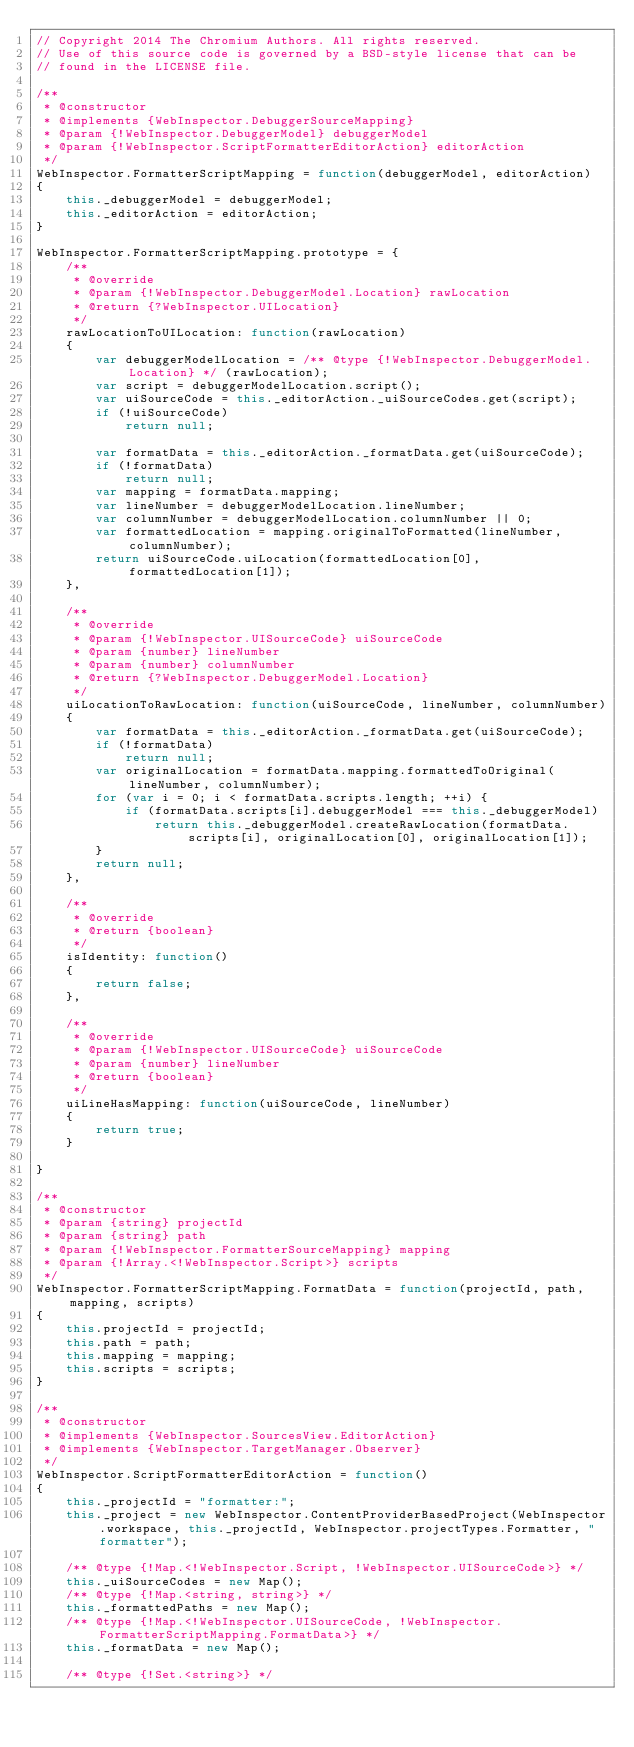Convert code to text. <code><loc_0><loc_0><loc_500><loc_500><_JavaScript_>// Copyright 2014 The Chromium Authors. All rights reserved.
// Use of this source code is governed by a BSD-style license that can be
// found in the LICENSE file.

/**
 * @constructor
 * @implements {WebInspector.DebuggerSourceMapping}
 * @param {!WebInspector.DebuggerModel} debuggerModel
 * @param {!WebInspector.ScriptFormatterEditorAction} editorAction
 */
WebInspector.FormatterScriptMapping = function(debuggerModel, editorAction)
{
    this._debuggerModel = debuggerModel;
    this._editorAction = editorAction;
}

WebInspector.FormatterScriptMapping.prototype = {
    /**
     * @override
     * @param {!WebInspector.DebuggerModel.Location} rawLocation
     * @return {?WebInspector.UILocation}
     */
    rawLocationToUILocation: function(rawLocation)
    {
        var debuggerModelLocation = /** @type {!WebInspector.DebuggerModel.Location} */ (rawLocation);
        var script = debuggerModelLocation.script();
        var uiSourceCode = this._editorAction._uiSourceCodes.get(script);
        if (!uiSourceCode)
            return null;

        var formatData = this._editorAction._formatData.get(uiSourceCode);
        if (!formatData)
            return null;
        var mapping = formatData.mapping;
        var lineNumber = debuggerModelLocation.lineNumber;
        var columnNumber = debuggerModelLocation.columnNumber || 0;
        var formattedLocation = mapping.originalToFormatted(lineNumber, columnNumber);
        return uiSourceCode.uiLocation(formattedLocation[0], formattedLocation[1]);
    },

    /**
     * @override
     * @param {!WebInspector.UISourceCode} uiSourceCode
     * @param {number} lineNumber
     * @param {number} columnNumber
     * @return {?WebInspector.DebuggerModel.Location}
     */
    uiLocationToRawLocation: function(uiSourceCode, lineNumber, columnNumber)
    {
        var formatData = this._editorAction._formatData.get(uiSourceCode);
        if (!formatData)
            return null;
        var originalLocation = formatData.mapping.formattedToOriginal(lineNumber, columnNumber);
        for (var i = 0; i < formatData.scripts.length; ++i) {
            if (formatData.scripts[i].debuggerModel === this._debuggerModel)
                return this._debuggerModel.createRawLocation(formatData.scripts[i], originalLocation[0], originalLocation[1]);
        }
        return null;
    },

    /**
     * @override
     * @return {boolean}
     */
    isIdentity: function()
    {
        return false;
    },

    /**
     * @override
     * @param {!WebInspector.UISourceCode} uiSourceCode
     * @param {number} lineNumber
     * @return {boolean}
     */
    uiLineHasMapping: function(uiSourceCode, lineNumber)
    {
        return true;
    }

}

/**
 * @constructor
 * @param {string} projectId
 * @param {string} path
 * @param {!WebInspector.FormatterSourceMapping} mapping
 * @param {!Array.<!WebInspector.Script>} scripts
 */
WebInspector.FormatterScriptMapping.FormatData = function(projectId, path, mapping, scripts)
{
    this.projectId = projectId;
    this.path = path;
    this.mapping = mapping;
    this.scripts = scripts;
}

/**
 * @constructor
 * @implements {WebInspector.SourcesView.EditorAction}
 * @implements {WebInspector.TargetManager.Observer}
 */
WebInspector.ScriptFormatterEditorAction = function()
{
    this._projectId = "formatter:";
    this._project = new WebInspector.ContentProviderBasedProject(WebInspector.workspace, this._projectId, WebInspector.projectTypes.Formatter, "formatter");

    /** @type {!Map.<!WebInspector.Script, !WebInspector.UISourceCode>} */
    this._uiSourceCodes = new Map();
    /** @type {!Map.<string, string>} */
    this._formattedPaths = new Map();
    /** @type {!Map.<!WebInspector.UISourceCode, !WebInspector.FormatterScriptMapping.FormatData>} */
    this._formatData = new Map();

    /** @type {!Set.<string>} */</code> 